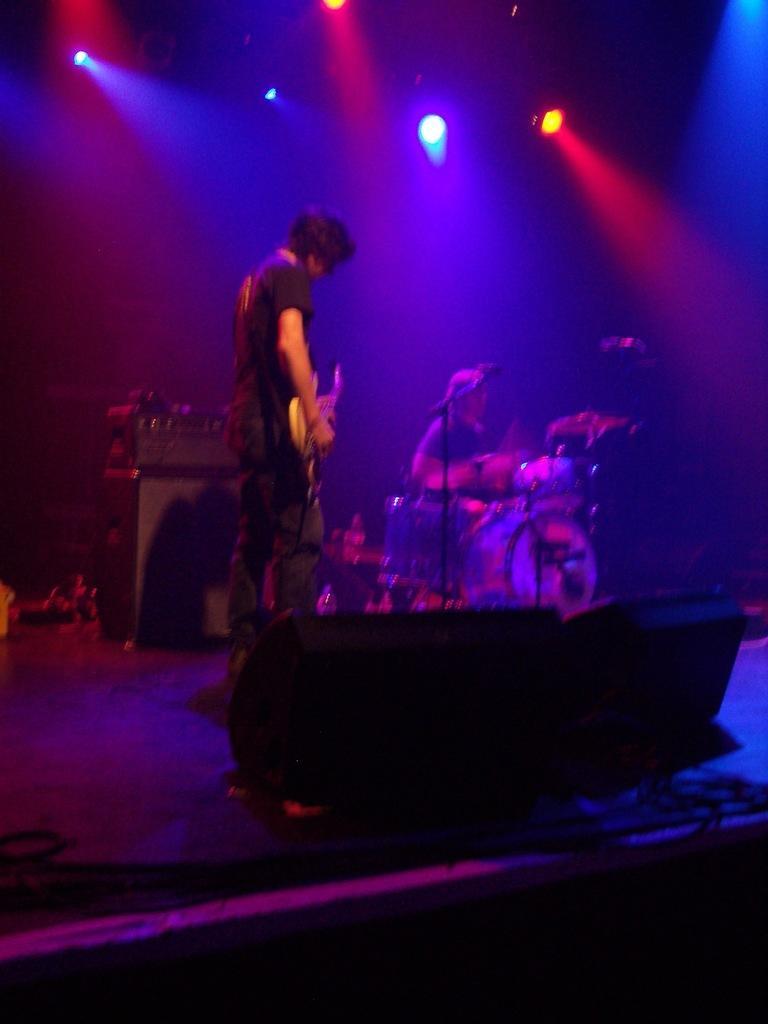Could you give a brief overview of what you see in this image? In this picture we can see two men playing musical instruments such as guitar, drums on stage and in the background we can see the lights. 